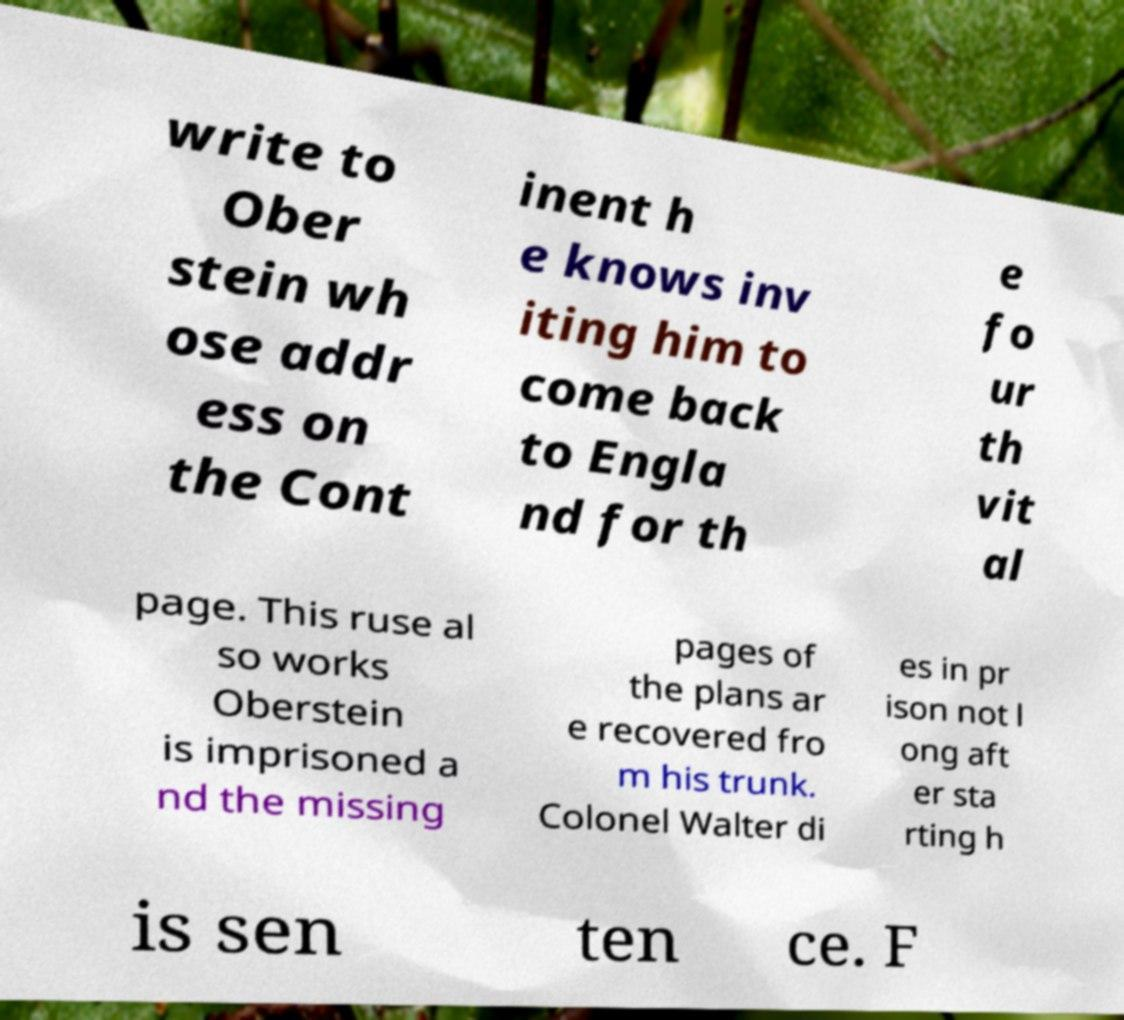Can you read and provide the text displayed in the image?This photo seems to have some interesting text. Can you extract and type it out for me? write to Ober stein wh ose addr ess on the Cont inent h e knows inv iting him to come back to Engla nd for th e fo ur th vit al page. This ruse al so works Oberstein is imprisoned a nd the missing pages of the plans ar e recovered fro m his trunk. Colonel Walter di es in pr ison not l ong aft er sta rting h is sen ten ce. F 